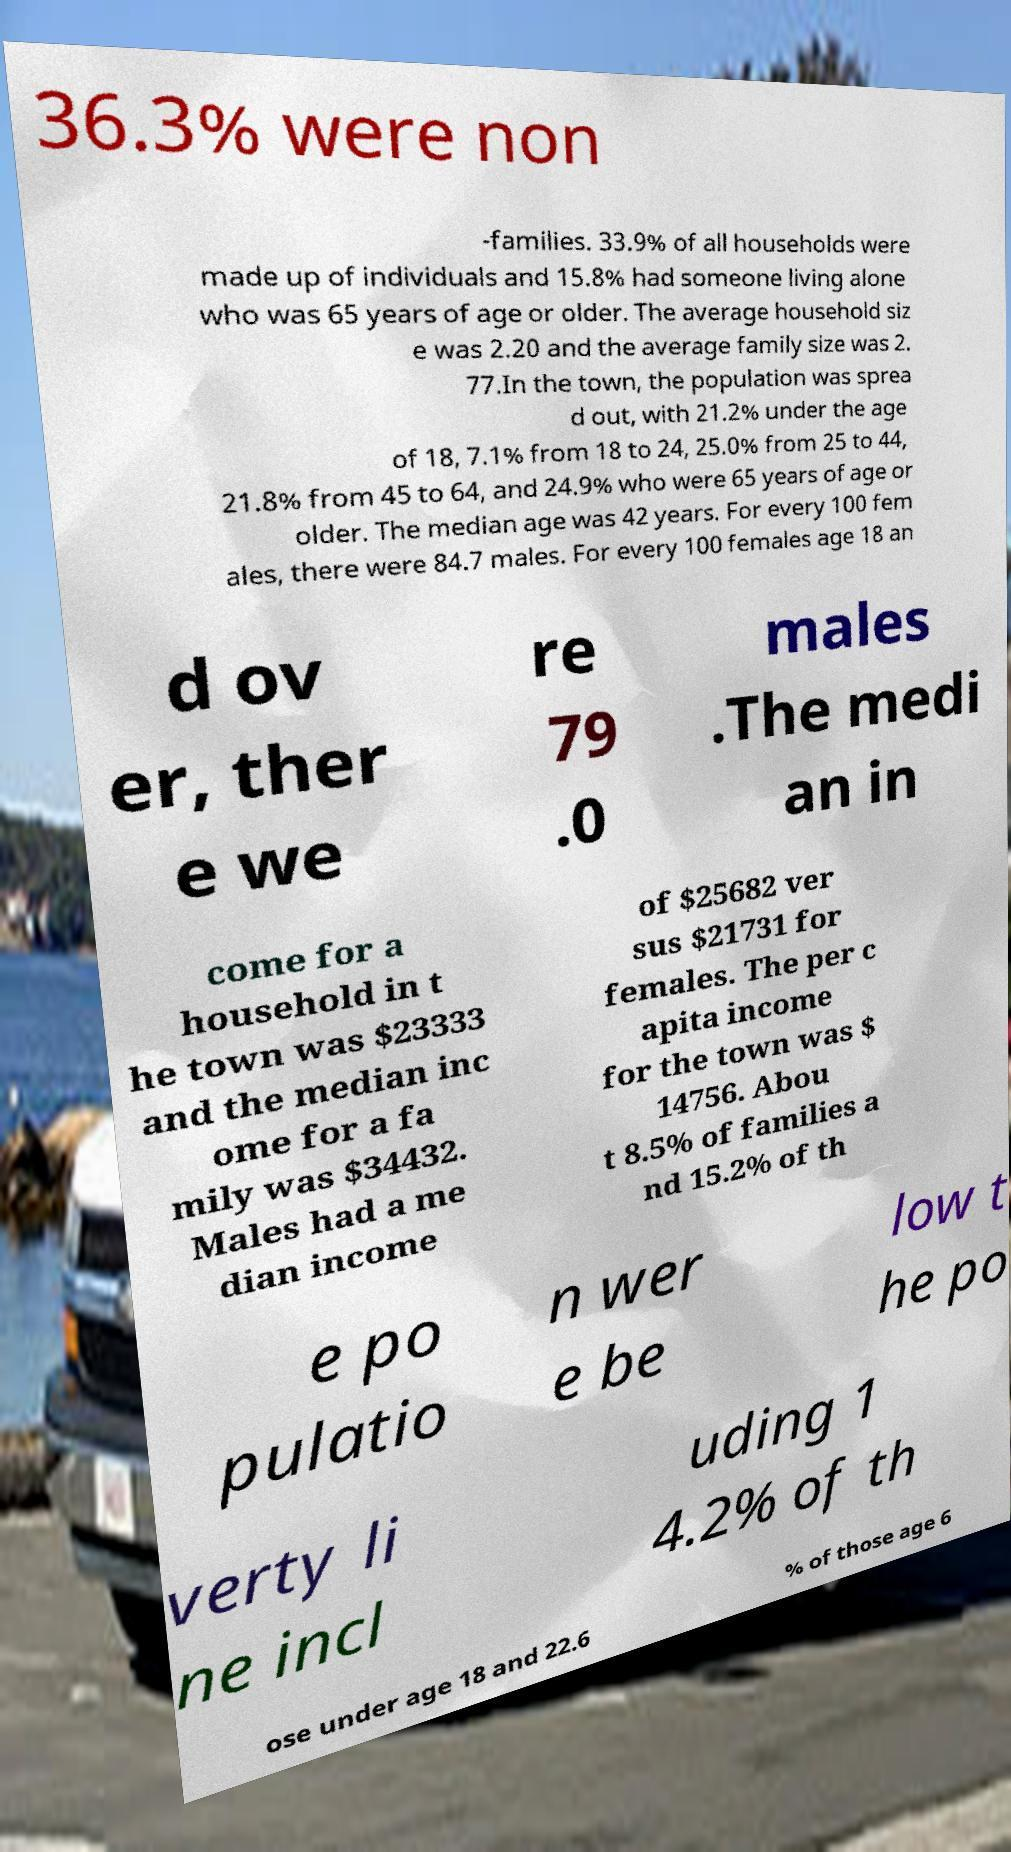Please identify and transcribe the text found in this image. 36.3% were non -families. 33.9% of all households were made up of individuals and 15.8% had someone living alone who was 65 years of age or older. The average household siz e was 2.20 and the average family size was 2. 77.In the town, the population was sprea d out, with 21.2% under the age of 18, 7.1% from 18 to 24, 25.0% from 25 to 44, 21.8% from 45 to 64, and 24.9% who were 65 years of age or older. The median age was 42 years. For every 100 fem ales, there were 84.7 males. For every 100 females age 18 an d ov er, ther e we re 79 .0 males .The medi an in come for a household in t he town was $23333 and the median inc ome for a fa mily was $34432. Males had a me dian income of $25682 ver sus $21731 for females. The per c apita income for the town was $ 14756. Abou t 8.5% of families a nd 15.2% of th e po pulatio n wer e be low t he po verty li ne incl uding 1 4.2% of th ose under age 18 and 22.6 % of those age 6 